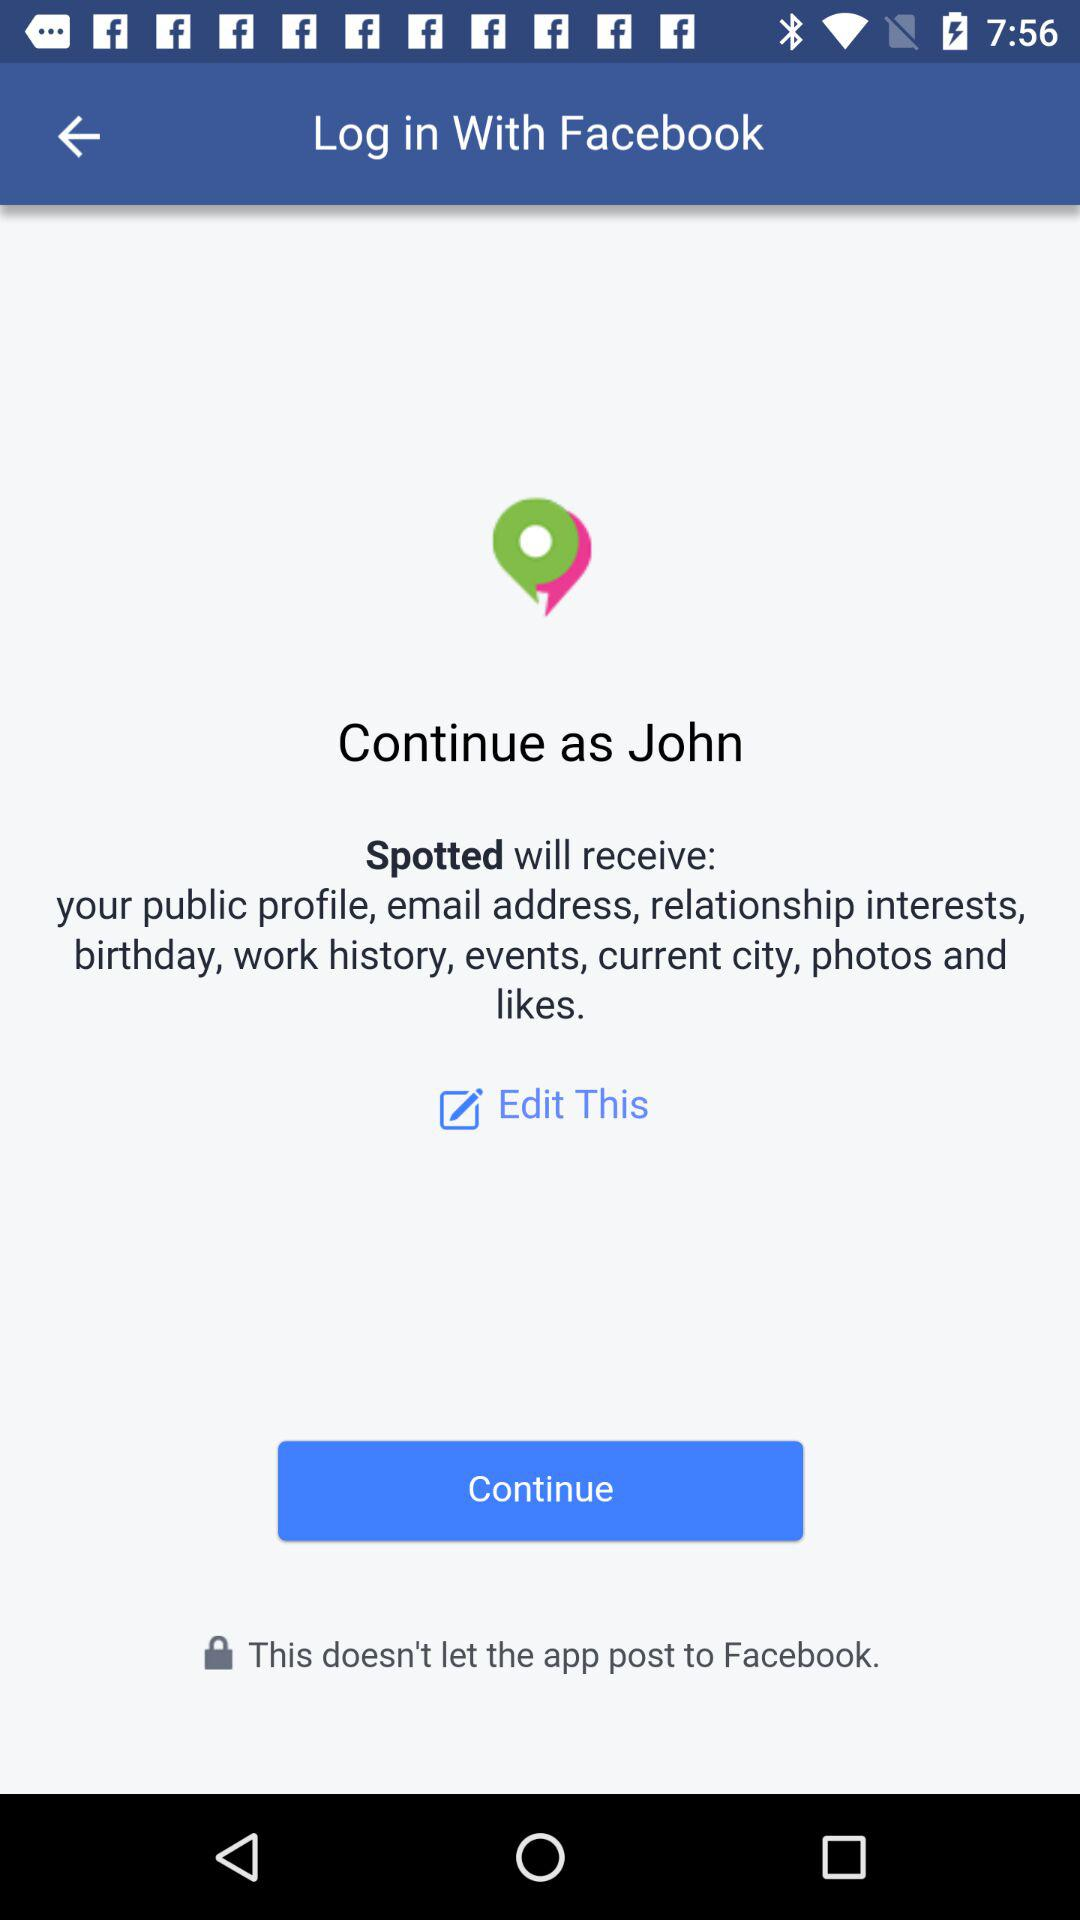What is the user name? The user name is John. 